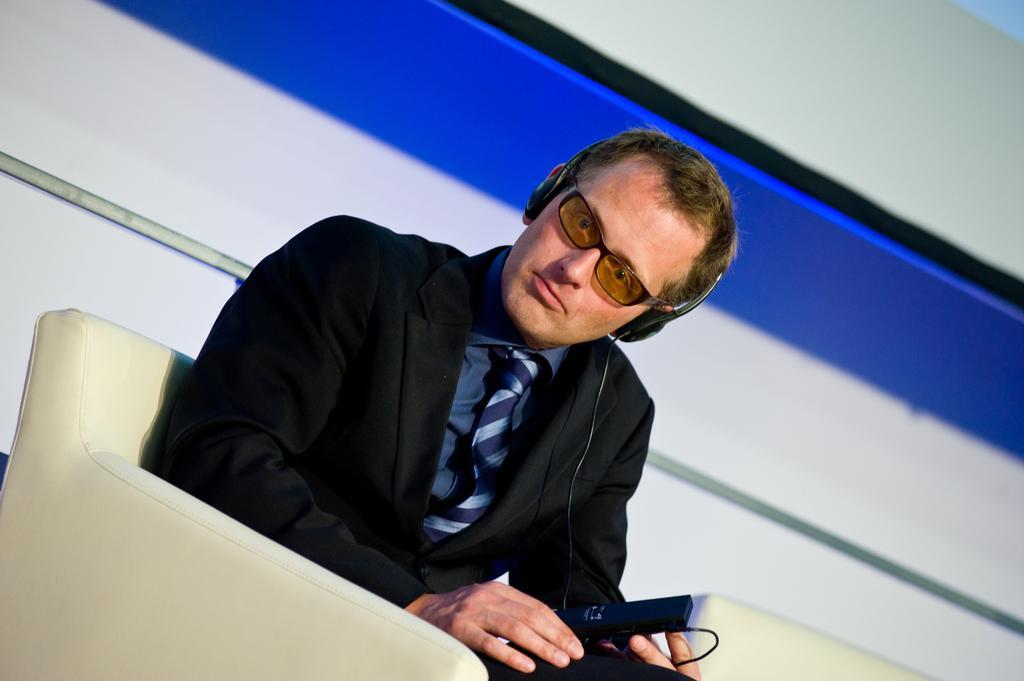How would you summarize this image in a sentence or two? In the image there is a person with goggles and he is sitting on the sofa. And he kept headphones and holding a black color object. Behind him there is a wall. 